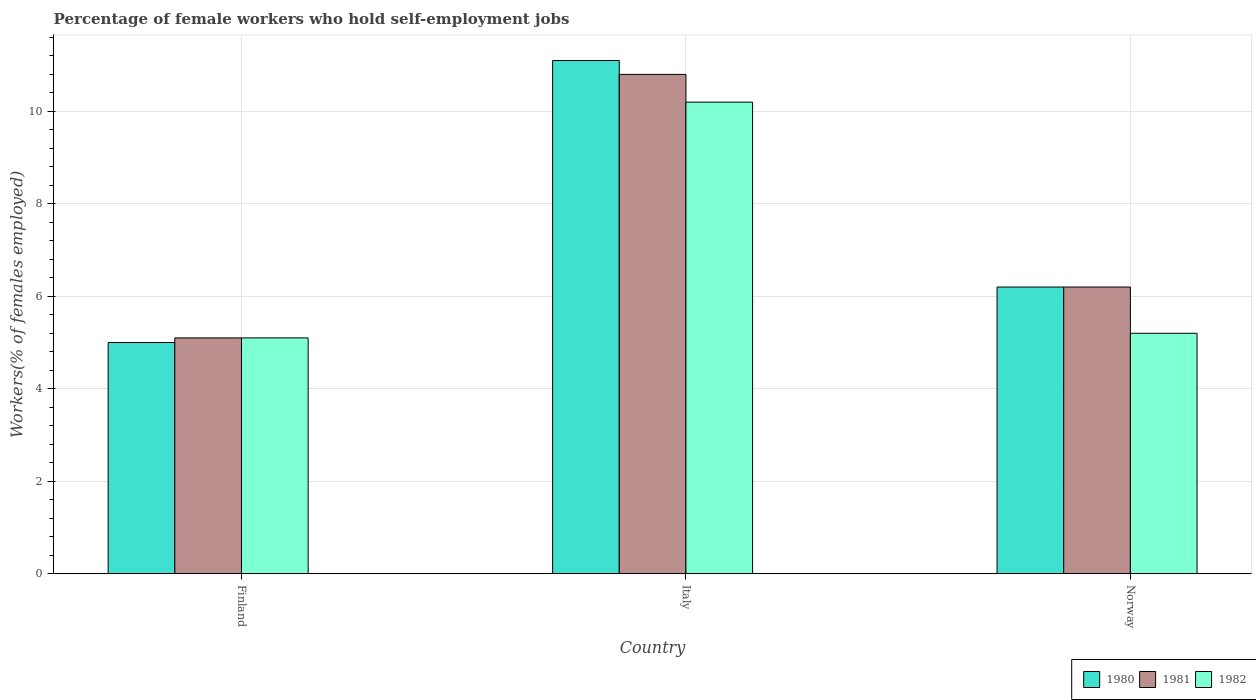How many different coloured bars are there?
Your response must be concise. 3. Are the number of bars on each tick of the X-axis equal?
Offer a very short reply. Yes. In how many cases, is the number of bars for a given country not equal to the number of legend labels?
Ensure brevity in your answer.  0. What is the percentage of self-employed female workers in 1982 in Finland?
Your answer should be very brief. 5.1. Across all countries, what is the maximum percentage of self-employed female workers in 1981?
Keep it short and to the point. 10.8. Across all countries, what is the minimum percentage of self-employed female workers in 1982?
Your answer should be compact. 5.1. What is the total percentage of self-employed female workers in 1980 in the graph?
Provide a short and direct response. 22.3. What is the difference between the percentage of self-employed female workers in 1980 in Italy and that in Norway?
Provide a succinct answer. 4.9. What is the difference between the percentage of self-employed female workers in 1980 in Norway and the percentage of self-employed female workers in 1981 in Italy?
Your answer should be compact. -4.6. What is the average percentage of self-employed female workers in 1981 per country?
Provide a succinct answer. 7.37. What is the difference between the percentage of self-employed female workers of/in 1982 and percentage of self-employed female workers of/in 1981 in Norway?
Your answer should be very brief. -1. In how many countries, is the percentage of self-employed female workers in 1982 greater than 3.2 %?
Offer a terse response. 3. What is the ratio of the percentage of self-employed female workers in 1982 in Finland to that in Norway?
Your response must be concise. 0.98. Is the percentage of self-employed female workers in 1982 in Finland less than that in Norway?
Your response must be concise. Yes. What is the difference between the highest and the second highest percentage of self-employed female workers in 1982?
Provide a short and direct response. 5. What is the difference between the highest and the lowest percentage of self-employed female workers in 1980?
Give a very brief answer. 6.1. Is the sum of the percentage of self-employed female workers in 1980 in Finland and Italy greater than the maximum percentage of self-employed female workers in 1981 across all countries?
Your answer should be very brief. Yes. How many bars are there?
Keep it short and to the point. 9. Are all the bars in the graph horizontal?
Make the answer very short. No. How many countries are there in the graph?
Provide a short and direct response. 3. What is the difference between two consecutive major ticks on the Y-axis?
Make the answer very short. 2. Are the values on the major ticks of Y-axis written in scientific E-notation?
Provide a short and direct response. No. Does the graph contain any zero values?
Provide a succinct answer. No. Does the graph contain grids?
Provide a succinct answer. Yes. How many legend labels are there?
Provide a short and direct response. 3. What is the title of the graph?
Your answer should be very brief. Percentage of female workers who hold self-employment jobs. What is the label or title of the X-axis?
Provide a succinct answer. Country. What is the label or title of the Y-axis?
Make the answer very short. Workers(% of females employed). What is the Workers(% of females employed) in 1980 in Finland?
Keep it short and to the point. 5. What is the Workers(% of females employed) of 1981 in Finland?
Provide a short and direct response. 5.1. What is the Workers(% of females employed) in 1982 in Finland?
Offer a terse response. 5.1. What is the Workers(% of females employed) of 1980 in Italy?
Offer a very short reply. 11.1. What is the Workers(% of females employed) in 1981 in Italy?
Provide a short and direct response. 10.8. What is the Workers(% of females employed) in 1982 in Italy?
Provide a succinct answer. 10.2. What is the Workers(% of females employed) of 1980 in Norway?
Your answer should be compact. 6.2. What is the Workers(% of females employed) of 1981 in Norway?
Your answer should be very brief. 6.2. What is the Workers(% of females employed) of 1982 in Norway?
Make the answer very short. 5.2. Across all countries, what is the maximum Workers(% of females employed) of 1980?
Your answer should be very brief. 11.1. Across all countries, what is the maximum Workers(% of females employed) in 1981?
Your response must be concise. 10.8. Across all countries, what is the maximum Workers(% of females employed) in 1982?
Your answer should be very brief. 10.2. Across all countries, what is the minimum Workers(% of females employed) in 1981?
Your answer should be compact. 5.1. Across all countries, what is the minimum Workers(% of females employed) of 1982?
Give a very brief answer. 5.1. What is the total Workers(% of females employed) of 1980 in the graph?
Your answer should be very brief. 22.3. What is the total Workers(% of females employed) of 1981 in the graph?
Your response must be concise. 22.1. What is the difference between the Workers(% of females employed) of 1980 in Finland and that in Italy?
Provide a succinct answer. -6.1. What is the difference between the Workers(% of females employed) in 1982 in Finland and that in Italy?
Your answer should be very brief. -5.1. What is the difference between the Workers(% of females employed) of 1981 in Finland and that in Norway?
Make the answer very short. -1.1. What is the difference between the Workers(% of females employed) of 1982 in Finland and that in Norway?
Offer a very short reply. -0.1. What is the difference between the Workers(% of females employed) of 1980 in Italy and that in Norway?
Give a very brief answer. 4.9. What is the difference between the Workers(% of females employed) in 1981 in Italy and that in Norway?
Keep it short and to the point. 4.6. What is the difference between the Workers(% of females employed) of 1982 in Italy and that in Norway?
Make the answer very short. 5. What is the difference between the Workers(% of females employed) of 1980 in Finland and the Workers(% of females employed) of 1981 in Italy?
Keep it short and to the point. -5.8. What is the difference between the Workers(% of females employed) in 1980 in Finland and the Workers(% of females employed) in 1982 in Italy?
Make the answer very short. -5.2. What is the difference between the Workers(% of females employed) of 1981 in Finland and the Workers(% of females employed) of 1982 in Italy?
Provide a short and direct response. -5.1. What is the difference between the Workers(% of females employed) of 1981 in Finland and the Workers(% of females employed) of 1982 in Norway?
Your answer should be compact. -0.1. What is the average Workers(% of females employed) in 1980 per country?
Keep it short and to the point. 7.43. What is the average Workers(% of females employed) in 1981 per country?
Make the answer very short. 7.37. What is the average Workers(% of females employed) of 1982 per country?
Make the answer very short. 6.83. What is the difference between the Workers(% of females employed) in 1981 and Workers(% of females employed) in 1982 in Finland?
Offer a very short reply. 0. What is the difference between the Workers(% of females employed) of 1980 and Workers(% of females employed) of 1982 in Italy?
Your answer should be very brief. 0.9. What is the difference between the Workers(% of females employed) in 1980 and Workers(% of females employed) in 1981 in Norway?
Your response must be concise. 0. What is the ratio of the Workers(% of females employed) in 1980 in Finland to that in Italy?
Make the answer very short. 0.45. What is the ratio of the Workers(% of females employed) of 1981 in Finland to that in Italy?
Offer a terse response. 0.47. What is the ratio of the Workers(% of females employed) of 1982 in Finland to that in Italy?
Make the answer very short. 0.5. What is the ratio of the Workers(% of females employed) in 1980 in Finland to that in Norway?
Your response must be concise. 0.81. What is the ratio of the Workers(% of females employed) of 1981 in Finland to that in Norway?
Your answer should be compact. 0.82. What is the ratio of the Workers(% of females employed) in 1982 in Finland to that in Norway?
Your response must be concise. 0.98. What is the ratio of the Workers(% of females employed) of 1980 in Italy to that in Norway?
Provide a succinct answer. 1.79. What is the ratio of the Workers(% of females employed) of 1981 in Italy to that in Norway?
Offer a terse response. 1.74. What is the ratio of the Workers(% of females employed) of 1982 in Italy to that in Norway?
Ensure brevity in your answer.  1.96. What is the difference between the highest and the second highest Workers(% of females employed) in 1981?
Provide a short and direct response. 4.6. What is the difference between the highest and the second highest Workers(% of females employed) of 1982?
Ensure brevity in your answer.  5. 